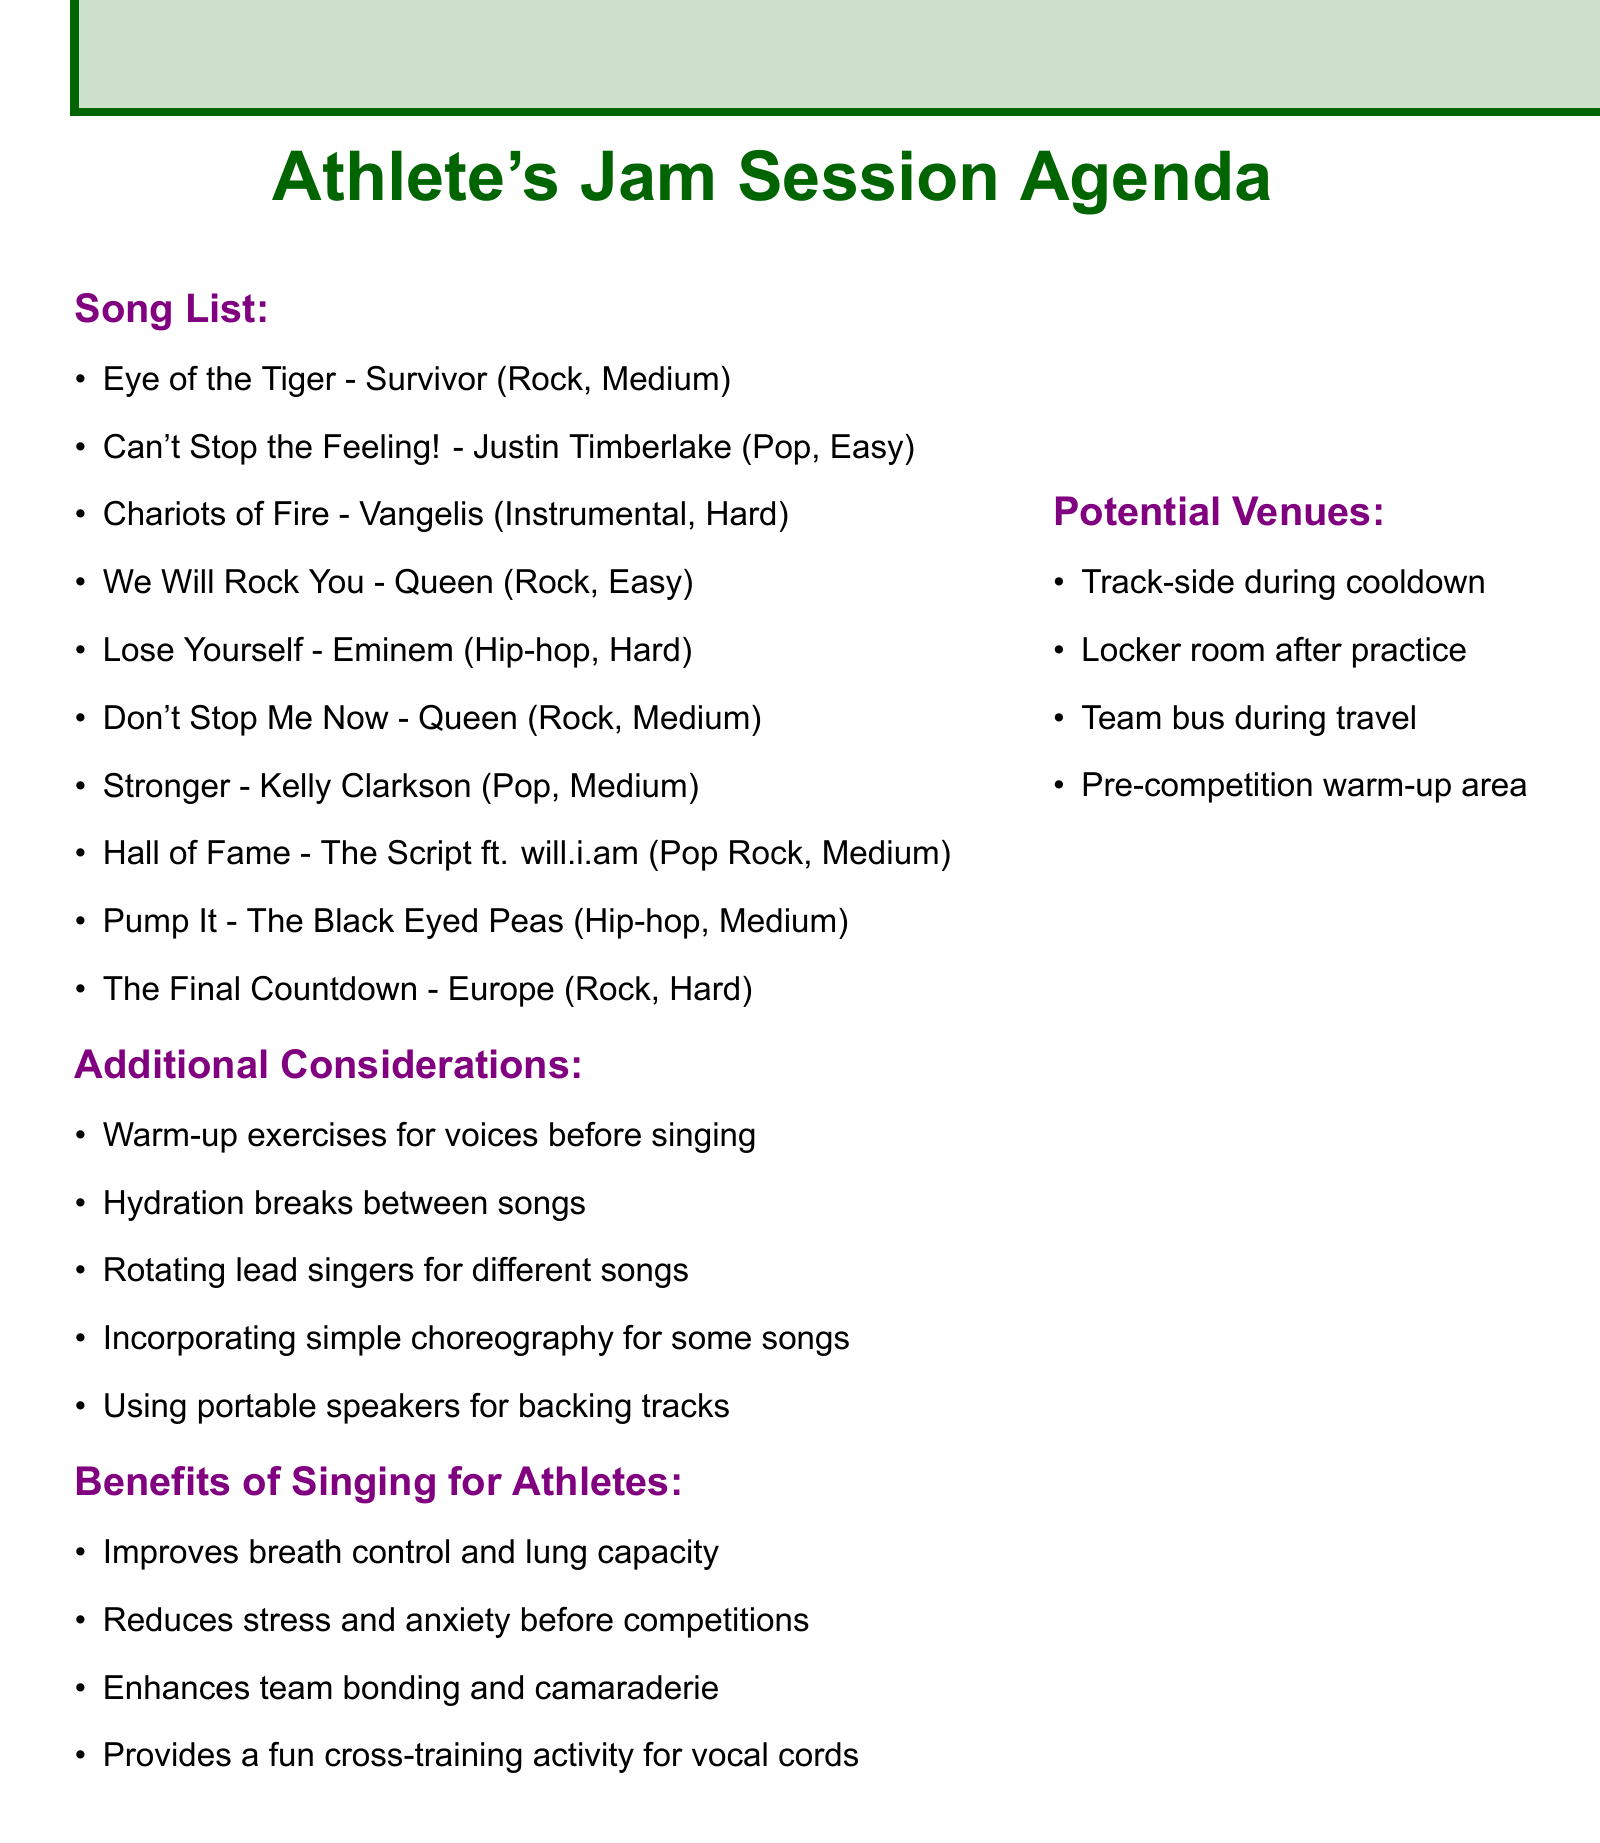What is the title of the first song? The first song listed in the document is "Eye of the Tiger."
Answer: Eye of the Tiger How many songs are classified as "Medium" difficulty? There are four songs with "Medium" difficulty in the document: "Eye of the Tiger," "Don't Stop Me Now," "Stronger," and "Hall of Fame."
Answer: 4 Which song is identified as "Hard" and is an instrumental piece? The only "Hard" instrumental song in the document is "Chariots of Fire."
Answer: Chariots of Fire What venue is suggested for singing on the team bus? The document mentions singing on the "Team bus during travel."
Answer: Team bus during travel What benefit of singing for athletes is mentioned in the document related to competition? One benefit mentioned is that singing "Reduces stress and anxiety before competitions."
Answer: Reduces stress and anxiety Which artist performed "We Will Rock You"? The artist for "We Will Rock You" is "Queen."
Answer: Queen What is the reason provided for including "Lose Yourself"? The reason for including "Lose Yourself" is "Fast-paced lyrics, great for improving breath control."
Answer: Fast-paced lyrics, great for improving breath control How many different genres are represented in the song list? The genres represented are Rock, Pop, Instrumental, and Hip-hop, totaling four different genres.
Answer: 4 What type of exercises are suggested before singing? The document suggests "Warm-up exercises for voices before singing."
Answer: Warm-up exercises for voices 